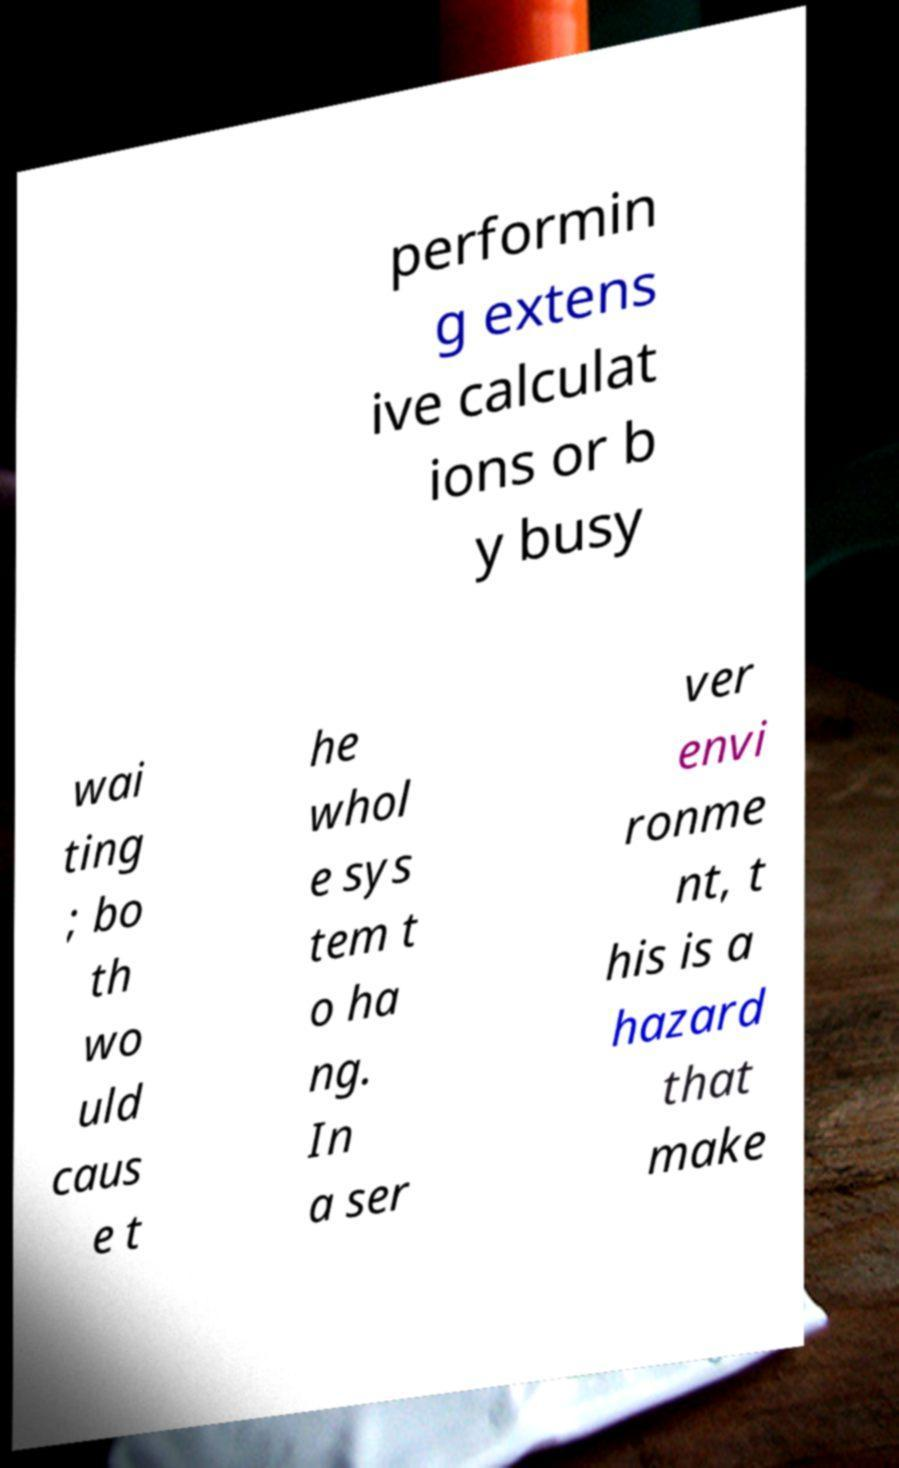Can you accurately transcribe the text from the provided image for me? performin g extens ive calculat ions or b y busy wai ting ; bo th wo uld caus e t he whol e sys tem t o ha ng. In a ser ver envi ronme nt, t his is a hazard that make 